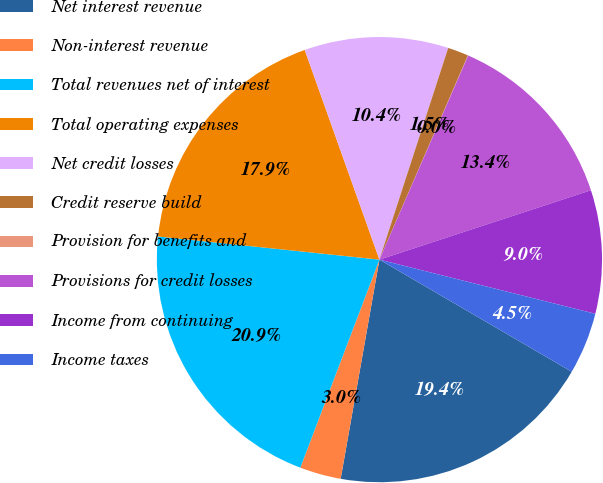Convert chart. <chart><loc_0><loc_0><loc_500><loc_500><pie_chart><fcel>Net interest revenue<fcel>Non-interest revenue<fcel>Total revenues net of interest<fcel>Total operating expenses<fcel>Net credit losses<fcel>Credit reserve build<fcel>Provision for benefits and<fcel>Provisions for credit losses<fcel>Income from continuing<fcel>Income taxes<nl><fcel>19.39%<fcel>3.0%<fcel>20.88%<fcel>17.9%<fcel>10.45%<fcel>1.51%<fcel>0.02%<fcel>13.43%<fcel>8.96%<fcel>4.49%<nl></chart> 